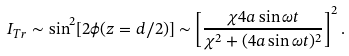Convert formula to latex. <formula><loc_0><loc_0><loc_500><loc_500>I _ { T r } \sim \sin ^ { 2 } [ 2 \phi ( z = d / 2 ) ] \sim \left [ \frac { \chi 4 a \sin \omega t } { \chi ^ { 2 } + ( 4 a \sin \omega t ) ^ { 2 } } \right ] ^ { 2 } .</formula> 